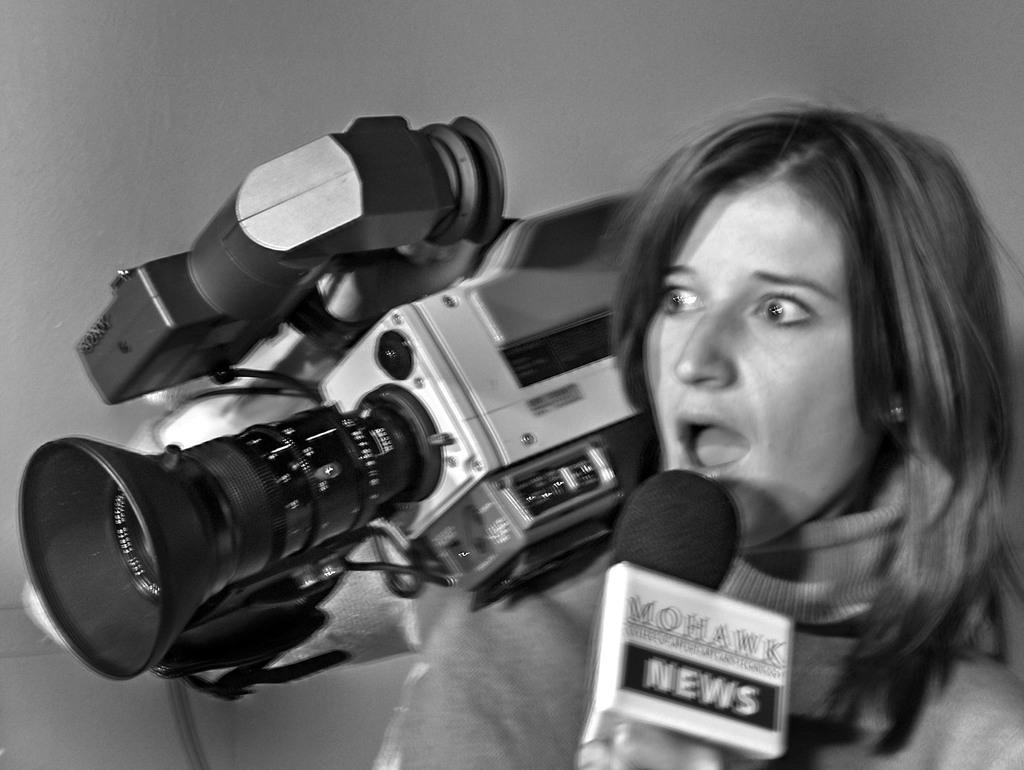Who is the main subject in the image? There is a woman in the image. What is the woman holding in her hands? The woman is holding a microphone and a camera. What might the woman be doing based on her actions? The woman has her mouth open, which suggests she might be speaking or singing into the microphone. How many spots can be seen on the woman's dress in the image? There is no mention of spots or a dress in the provided facts, so it cannot be determined from the image. 